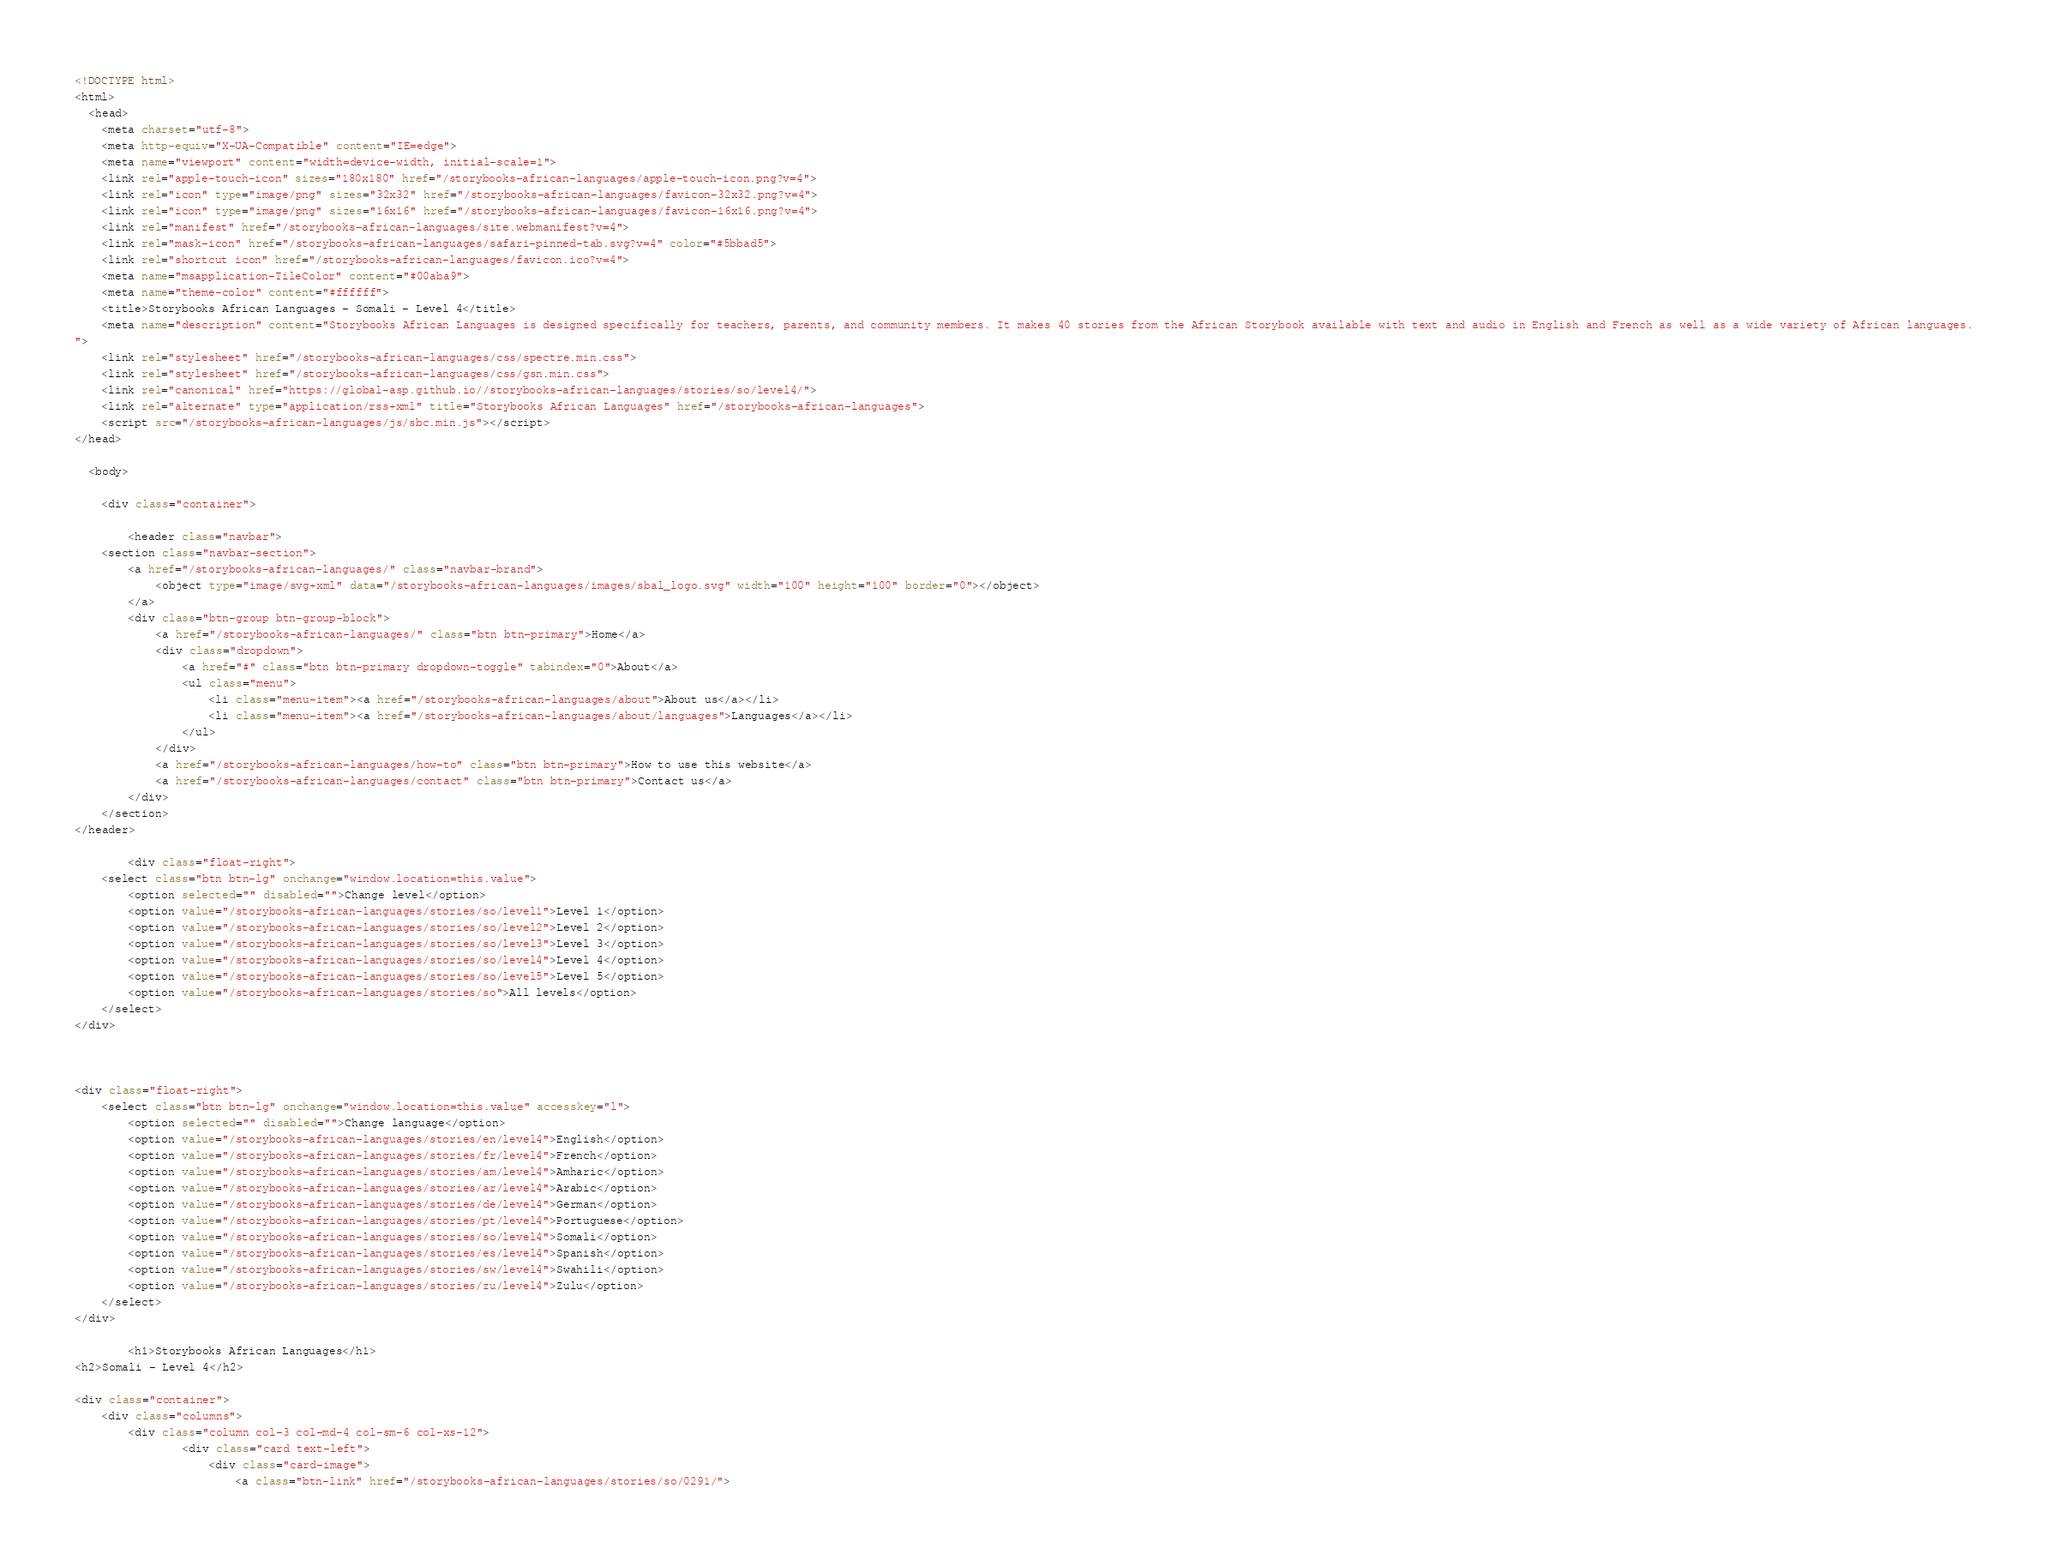Convert code to text. <code><loc_0><loc_0><loc_500><loc_500><_HTML_><!DOCTYPE html>
<html>
  <head>
	<meta charset="utf-8">
	<meta http-equiv="X-UA-Compatible" content="IE=edge">
	<meta name="viewport" content="width=device-width, initial-scale=1">
	<link rel="apple-touch-icon" sizes="180x180" href="/storybooks-african-languages/apple-touch-icon.png?v=4">
	<link rel="icon" type="image/png" sizes="32x32" href="/storybooks-african-languages/favicon-32x32.png?v=4">
	<link rel="icon" type="image/png" sizes="16x16" href="/storybooks-african-languages/favicon-16x16.png?v=4">
	<link rel="manifest" href="/storybooks-african-languages/site.webmanifest?v=4">
	<link rel="mask-icon" href="/storybooks-african-languages/safari-pinned-tab.svg?v=4" color="#5bbad5">
	<link rel="shortcut icon" href="/storybooks-african-languages/favicon.ico?v=4">
	<meta name="msapplication-TileColor" content="#00aba9">
	<meta name="theme-color" content="#ffffff">
	<title>Storybooks African Languages - Somali - Level 4</title>
	<meta name="description" content="Storybooks African Languages is designed specifically for teachers, parents, and community members. It makes 40 stories from the African Storybook available with text and audio in English and French as well as a wide variety of African languages.
">
	<link rel="stylesheet" href="/storybooks-african-languages/css/spectre.min.css">
	<link rel="stylesheet" href="/storybooks-african-languages/css/gsn.min.css">
	<link rel="canonical" href="https://global-asp.github.io//storybooks-african-languages/stories/so/level4/">
	<link rel="alternate" type="application/rss+xml" title="Storybooks African Languages" href="/storybooks-african-languages">
	<script src="/storybooks-african-languages/js/sbc.min.js"></script>
</head>

  <body>

    <div class="container">

        <header class="navbar">
	<section class="navbar-section">
		<a href="/storybooks-african-languages/" class="navbar-brand">
			<object type="image/svg+xml" data="/storybooks-african-languages/images/sbal_logo.svg" width="100" height="100" border="0"></object>
		</a>
		<div class="btn-group btn-group-block">
			<a href="/storybooks-african-languages/" class="btn btn-primary">Home</a>
			<div class="dropdown">
				<a href="#" class="btn btn-primary dropdown-toggle" tabindex="0">About</a>
				<ul class="menu">
					<li class="menu-item"><a href="/storybooks-african-languages/about">About us</a></li>
					<li class="menu-item"><a href="/storybooks-african-languages/about/languages">Languages</a></li>
				</ul>
			</div>
			<a href="/storybooks-african-languages/how-to" class="btn btn-primary">How to use this website</a>
			<a href="/storybooks-african-languages/contact" class="btn btn-primary">Contact us</a>
		</div>
	</section>
</header>

        <div class="float-right">
	<select class="btn btn-lg" onchange="window.location=this.value">
		<option selected="" disabled="">Change level</option>
		<option value="/storybooks-african-languages/stories/so/level1">Level 1</option>
		<option value="/storybooks-african-languages/stories/so/level2">Level 2</option>
		<option value="/storybooks-african-languages/stories/so/level3">Level 3</option>
		<option value="/storybooks-african-languages/stories/so/level4">Level 4</option>
		<option value="/storybooks-african-languages/stories/so/level5">Level 5</option>
		<option value="/storybooks-african-languages/stories/so">All levels</option>
	</select>
</div>

        

<div class="float-right">
	<select class="btn btn-lg" onchange="window.location=this.value" accesskey="l">
		<option selected="" disabled="">Change language</option>
		<option value="/storybooks-african-languages/stories/en/level4">English</option>
		<option value="/storybooks-african-languages/stories/fr/level4">French</option>
		<option value="/storybooks-african-languages/stories/am/level4">Amharic</option>
		<option value="/storybooks-african-languages/stories/ar/level4">Arabic</option>
		<option value="/storybooks-african-languages/stories/de/level4">German</option>
		<option value="/storybooks-african-languages/stories/pt/level4">Portuguese</option>
		<option value="/storybooks-african-languages/stories/so/level4">Somali</option>
		<option value="/storybooks-african-languages/stories/es/level4">Spanish</option>
		<option value="/storybooks-african-languages/stories/sw/level4">Swahili</option>
		<option value="/storybooks-african-languages/stories/zu/level4">Zulu</option>
	</select>
</div>

        <h1>Storybooks African Languages</h1>
<h2>Somali - Level 4</h2>

<div class="container">
	<div class="columns">
		<div class="column col-3 col-md-4 col-sm-6 col-xs-12">
				<div class="card text-left">
					<div class="card-image">
						<a class="btn-link" href="/storybooks-african-languages/stories/so/0291/"></code> 